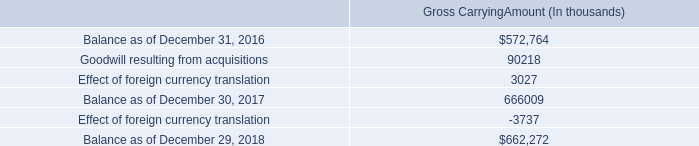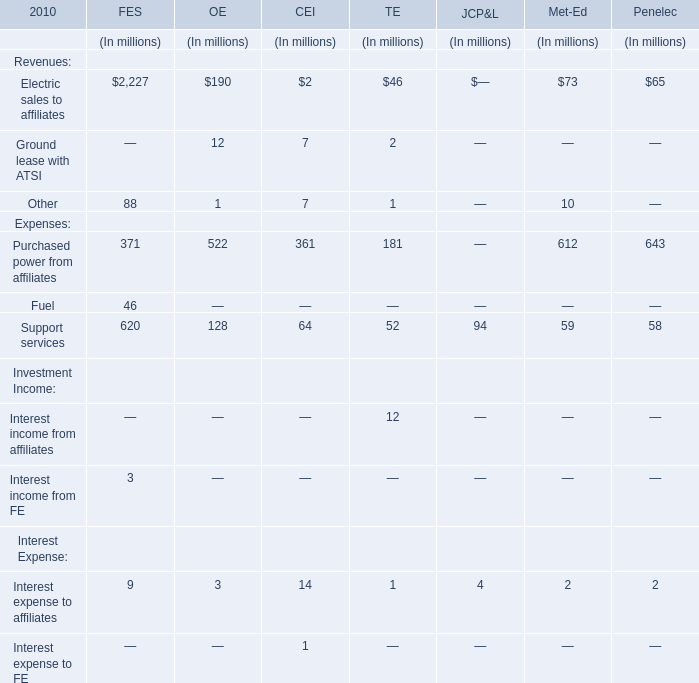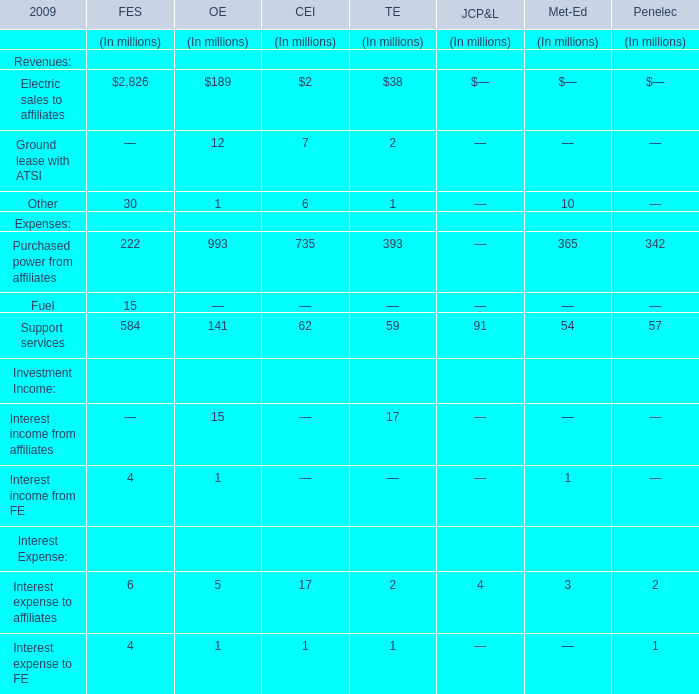What is the proportion of all Revenues of TE that are greater than 40 to the total amount of Revenues of TE, in 2010? 
Computations: (46 / ((46 + 2) + 1))
Answer: 0.93878. 